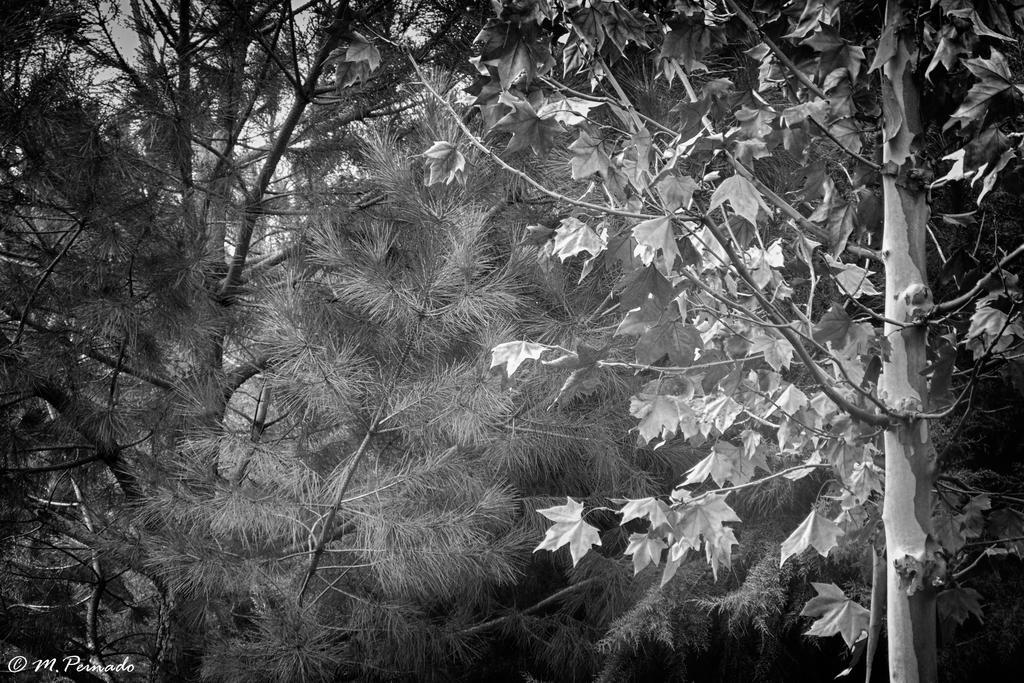How would you summarize this image in a sentence or two? This is a black and white picture. I can see trees and there is a watermark on the image. 